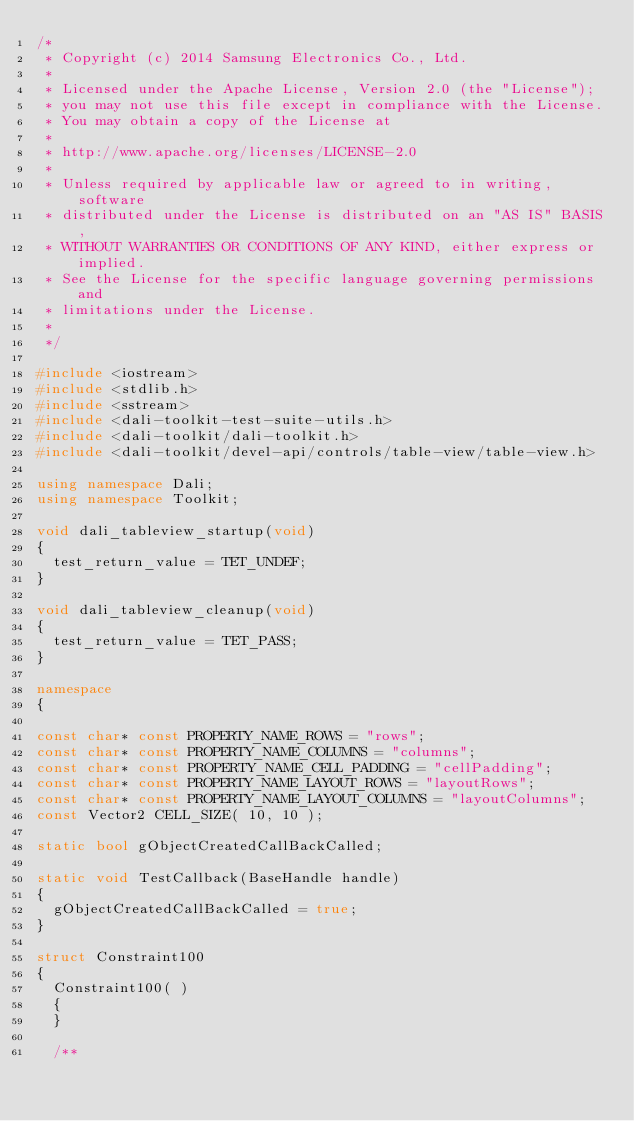<code> <loc_0><loc_0><loc_500><loc_500><_C++_>/*
 * Copyright (c) 2014 Samsung Electronics Co., Ltd.
 *
 * Licensed under the Apache License, Version 2.0 (the "License");
 * you may not use this file except in compliance with the License.
 * You may obtain a copy of the License at
 *
 * http://www.apache.org/licenses/LICENSE-2.0
 *
 * Unless required by applicable law or agreed to in writing, software
 * distributed under the License is distributed on an "AS IS" BASIS,
 * WITHOUT WARRANTIES OR CONDITIONS OF ANY KIND, either express or implied.
 * See the License for the specific language governing permissions and
 * limitations under the License.
 *
 */

#include <iostream>
#include <stdlib.h>
#include <sstream>
#include <dali-toolkit-test-suite-utils.h>
#include <dali-toolkit/dali-toolkit.h>
#include <dali-toolkit/devel-api/controls/table-view/table-view.h>

using namespace Dali;
using namespace Toolkit;

void dali_tableview_startup(void)
{
  test_return_value = TET_UNDEF;
}

void dali_tableview_cleanup(void)
{
  test_return_value = TET_PASS;
}

namespace
{

const char* const PROPERTY_NAME_ROWS = "rows";
const char* const PROPERTY_NAME_COLUMNS = "columns";
const char* const PROPERTY_NAME_CELL_PADDING = "cellPadding";
const char* const PROPERTY_NAME_LAYOUT_ROWS = "layoutRows";
const char* const PROPERTY_NAME_LAYOUT_COLUMNS = "layoutColumns";
const Vector2 CELL_SIZE( 10, 10 );

static bool gObjectCreatedCallBackCalled;

static void TestCallback(BaseHandle handle)
{
  gObjectCreatedCallBackCalled = true;
}

struct Constraint100
{
  Constraint100( )
  {
  }

  /**</code> 